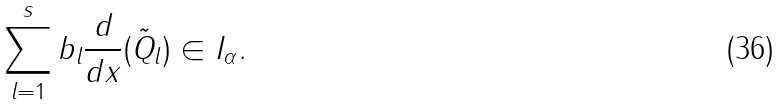Convert formula to latex. <formula><loc_0><loc_0><loc_500><loc_500>\sum _ { l = 1 } ^ { s } b _ { l } \frac { d } { d x } ( \tilde { Q } _ { l } ) \in I _ { \alpha } .</formula> 